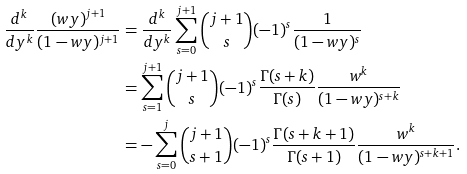<formula> <loc_0><loc_0><loc_500><loc_500>\frac { d ^ { k } } { d y ^ { k } } \frac { ( w y ) ^ { j + 1 } } { ( 1 - w y ) ^ { j + 1 } } & = \frac { d ^ { k } } { d y ^ { k } } \sum _ { s = 0 } ^ { j + 1 } \binom { j + 1 } { s } ( - 1 ) ^ { s } \frac { 1 } { ( 1 - w y ) ^ { s } } \\ & = \sum _ { s = 1 } ^ { j + 1 } \binom { j + 1 } { s } ( - 1 ) ^ { s } \frac { \Gamma ( s + k ) } { \Gamma ( s ) } \frac { w ^ { k } } { ( 1 - w y ) ^ { s + k } } \\ & = - \sum _ { s = 0 } ^ { j } \binom { j + 1 } { s + 1 } ( - 1 ) ^ { s } \frac { \Gamma ( s + k + 1 ) } { \Gamma ( s + 1 ) } \frac { w ^ { k } } { ( 1 - w y ) ^ { s + k + 1 } } .</formula> 